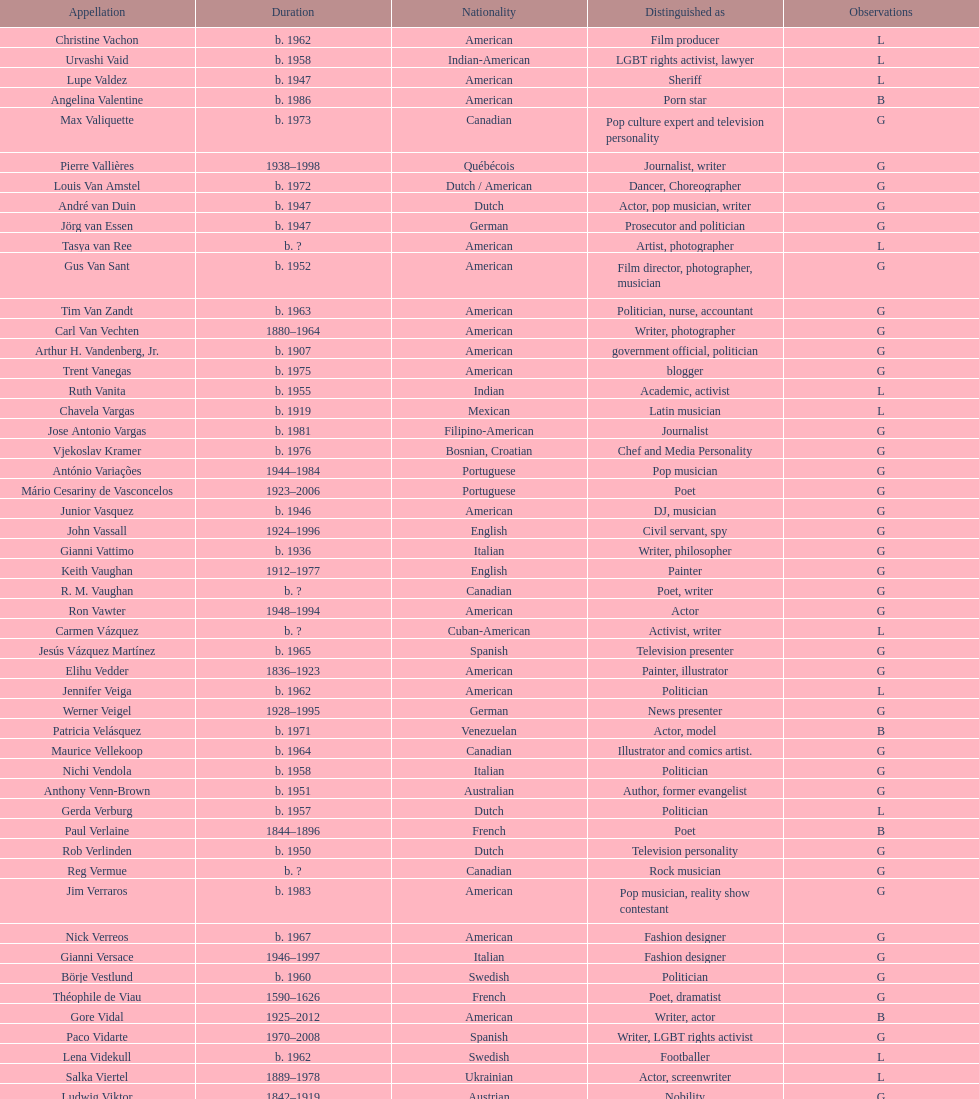Which nationality had the most notable poets? French. 